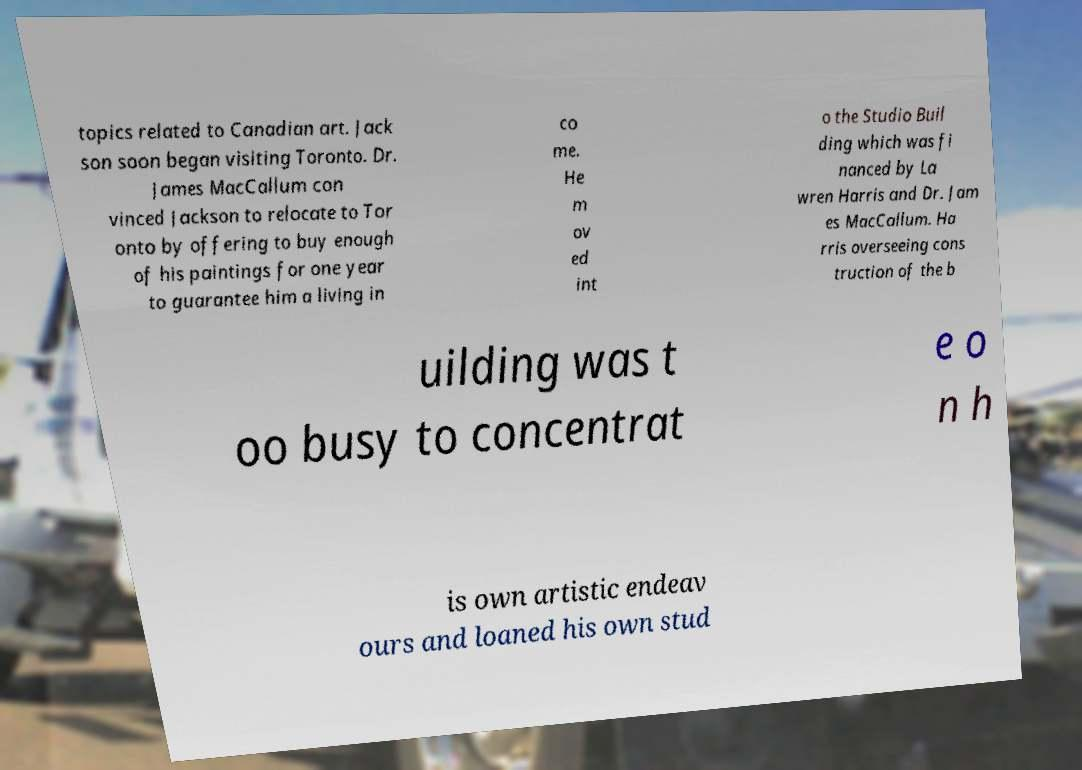Please read and relay the text visible in this image. What does it say? topics related to Canadian art. Jack son soon began visiting Toronto. Dr. James MacCallum con vinced Jackson to relocate to Tor onto by offering to buy enough of his paintings for one year to guarantee him a living in co me. He m ov ed int o the Studio Buil ding which was fi nanced by La wren Harris and Dr. Jam es MacCallum. Ha rris overseeing cons truction of the b uilding was t oo busy to concentrat e o n h is own artistic endeav ours and loaned his own stud 